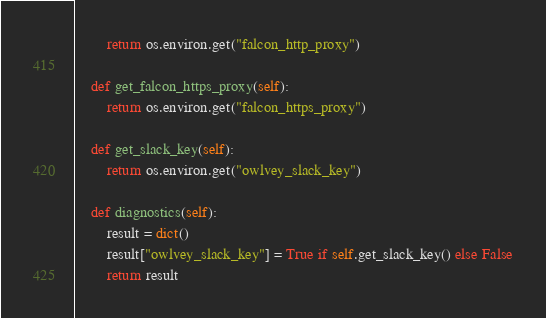<code> <loc_0><loc_0><loc_500><loc_500><_Python_>        return os.environ.get("falcon_http_proxy")

    def get_falcon_https_proxy(self):
        return os.environ.get("falcon_https_proxy")

    def get_slack_key(self):
        return os.environ.get("owlvey_slack_key")

    def diagnostics(self):
        result = dict()
        result["owlvey_slack_key"] = True if self.get_slack_key() else False
        return result</code> 